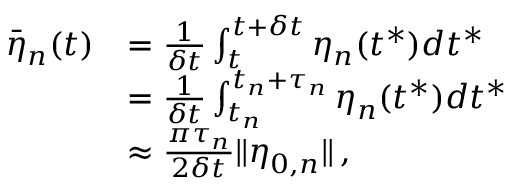<formula> <loc_0><loc_0><loc_500><loc_500>\begin{array} { r l } { \bar { \eta } _ { n } ( t ) } & { = \frac { 1 } { \delta t } \int _ { t } ^ { t + \delta t } \eta _ { n } ( t ^ { * } ) d t ^ { * } } \\ & { = \frac { 1 } { \delta t } \int _ { t _ { n } } ^ { t _ { n } + \tau _ { n } } \eta _ { n } ( t ^ { * } ) d t ^ { * } } \\ & { \approx \frac { \pi \tau _ { n } } { 2 \delta t } \| \eta _ { 0 , n } \| \, , } \end{array}</formula> 